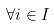<formula> <loc_0><loc_0><loc_500><loc_500>\forall i \in I</formula> 